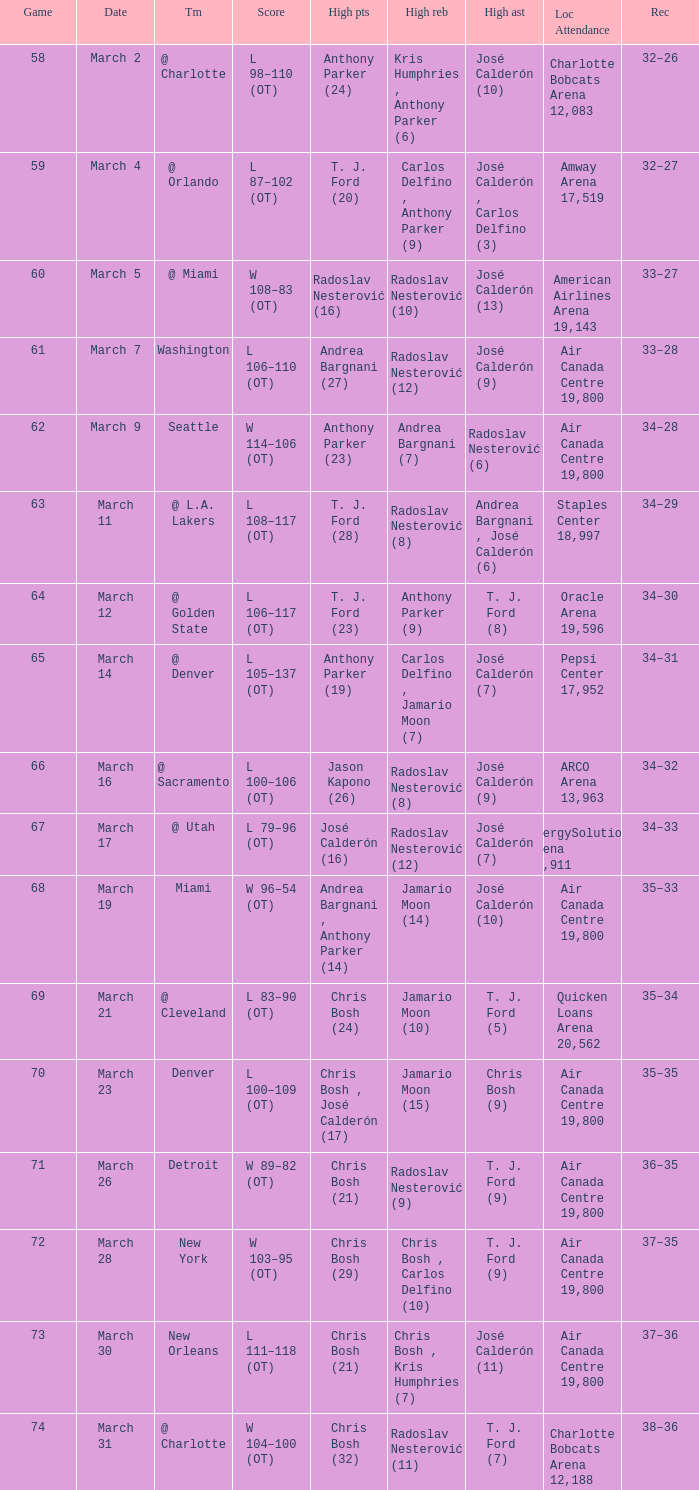What numbered game featured a High rebounds of radoslav nesterović (8), and a High assists of josé calderón (9)? 1.0. 